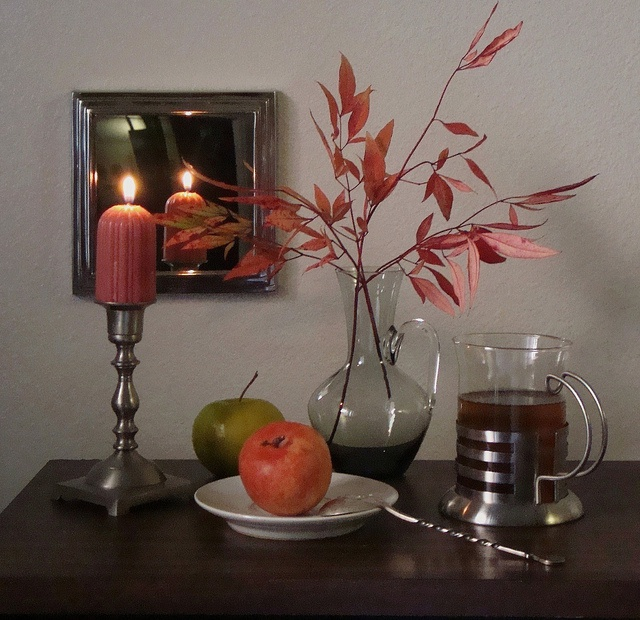Describe the objects in this image and their specific colors. I can see dining table in gray, black, and maroon tones, cup in gray and black tones, vase in gray and black tones, apple in gray, brown, and maroon tones, and apple in gray, olive, and black tones in this image. 